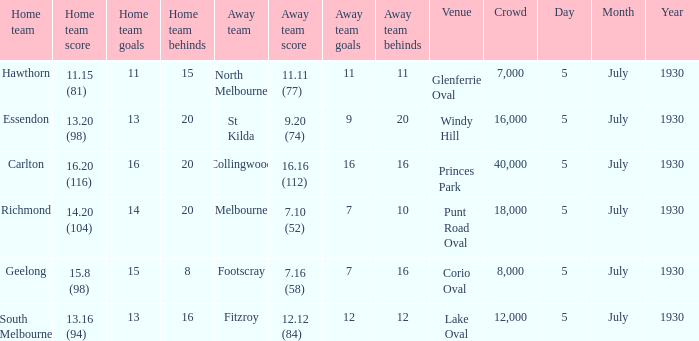On which day does the squad compete at punt road oval? 5 July 1930. Help me parse the entirety of this table. {'header': ['Home team', 'Home team score', 'Home team goals', 'Home team behinds', 'Away team', 'Away team score', 'Away team goals', 'Away team behinds', 'Venue', 'Crowd', 'Day', 'Month', 'Year'], 'rows': [['Hawthorn', '11.15 (81)', '11', '15', 'North Melbourne', '11.11 (77)', '11', '11', 'Glenferrie Oval', '7,000', '5', 'July', '1930'], ['Essendon', '13.20 (98)', '13', '20', 'St Kilda', '9.20 (74)', '9', '20', 'Windy Hill', '16,000', '5', 'July', '1930'], ['Carlton', '16.20 (116)', '16', '20', 'Collingwood', '16.16 (112)', '16', '16', 'Princes Park', '40,000', '5', 'July', '1930'], ['Richmond', '14.20 (104)', '14', '20', 'Melbourne', '7.10 (52)', '7', '10', 'Punt Road Oval', '18,000', '5', 'July', '1930'], ['Geelong', '15.8 (98)', '15', '8', 'Footscray', '7.16 (58)', '7', '16', 'Corio Oval', '8,000', '5', 'July', '1930'], ['South Melbourne', '13.16 (94)', '13', '16', 'Fitzroy', '12.12 (84)', '12', '12', 'Lake Oval', '12,000', '5', 'July', '1930']]} 